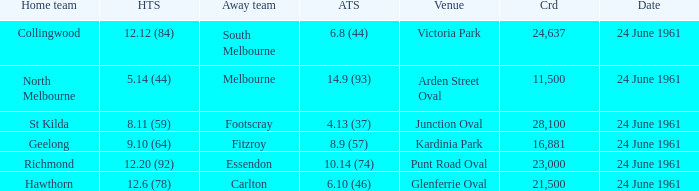10 (64)? 24 June 1961. 